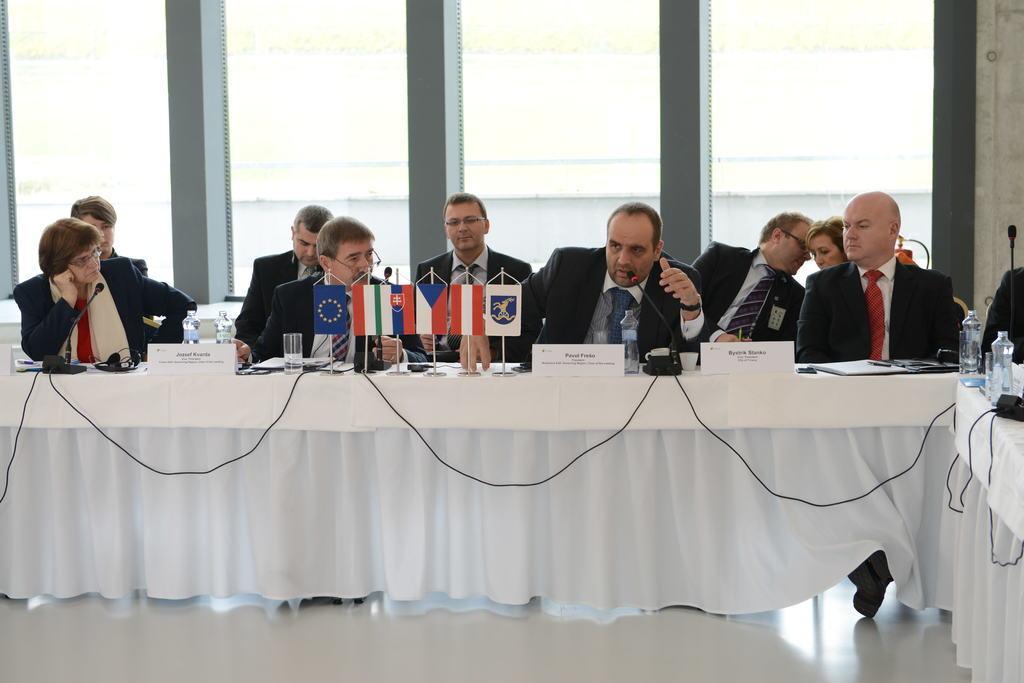Describe this image in one or two sentences. In this picture we can see a few people sitting on the chair. There are mice, glasses, bottles, devices and other objects on the table. We can see a white cloth from left to right. 